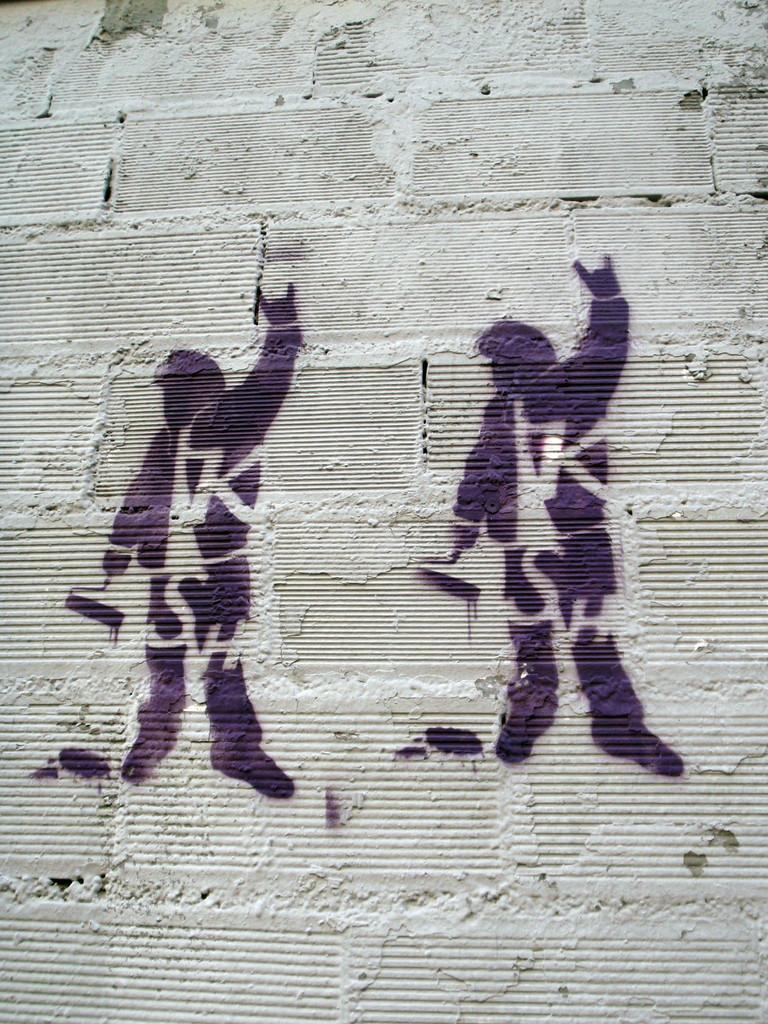What color is the wall in the image? The wall in the image is grey. What is on the wall in the image? There is art on the wall in the image. What color is the art on the wall? The art on the wall is black in color. How does the mist affect the art on the wall in the image? There is no mist present in the image, so it cannot affect the art on the wall. 